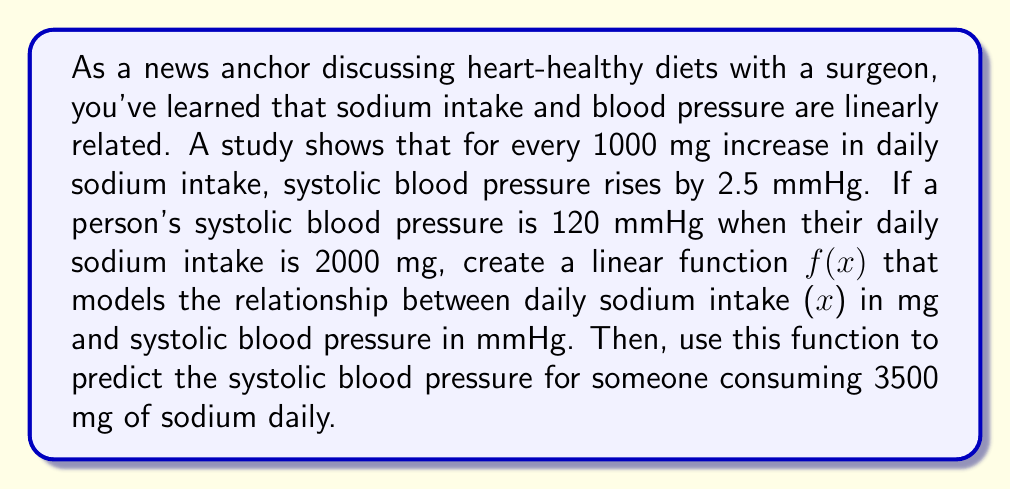Show me your answer to this math problem. 1) Let's define our linear function: $f(x) = mx + b$, where:
   $f(x)$ is the systolic blood pressure in mmHg
   $x$ is the daily sodium intake in mg
   $m$ is the slope
   $b$ is the y-intercept

2) Calculate the slope $m$:
   $m = \frac{\text{change in blood pressure}}{\text{change in sodium intake}} = \frac{2.5 \text{ mmHg}}{1000 \text{ mg}} = 0.0025 \text{ mmHg/mg}$

3) Use the given point (2000, 120) to find $b$:
   $120 = 0.0025(2000) + b$
   $120 = 5 + b$
   $b = 115$

4) Our linear function is:
   $f(x) = 0.0025x + 115$

5) To predict blood pressure for 3500 mg sodium intake:
   $f(3500) = 0.0025(3500) + 115$
   $f(3500) = 8.75 + 115 = 123.75$
Answer: $f(x) = 0.0025x + 115$; 123.75 mmHg 